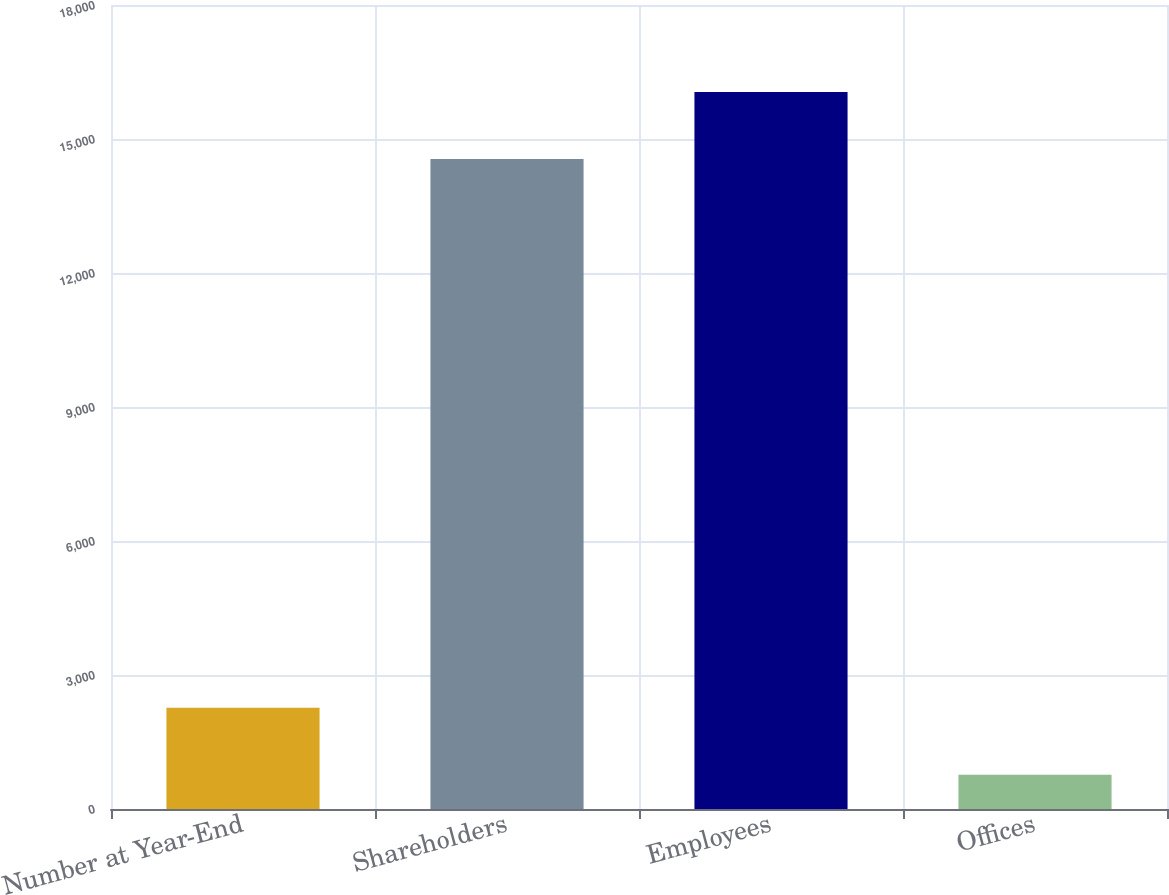<chart> <loc_0><loc_0><loc_500><loc_500><bar_chart><fcel>Number at Year-End<fcel>Shareholders<fcel>Employees<fcel>Offices<nl><fcel>2267.6<fcel>14551<fcel>16052.6<fcel>766<nl></chart> 